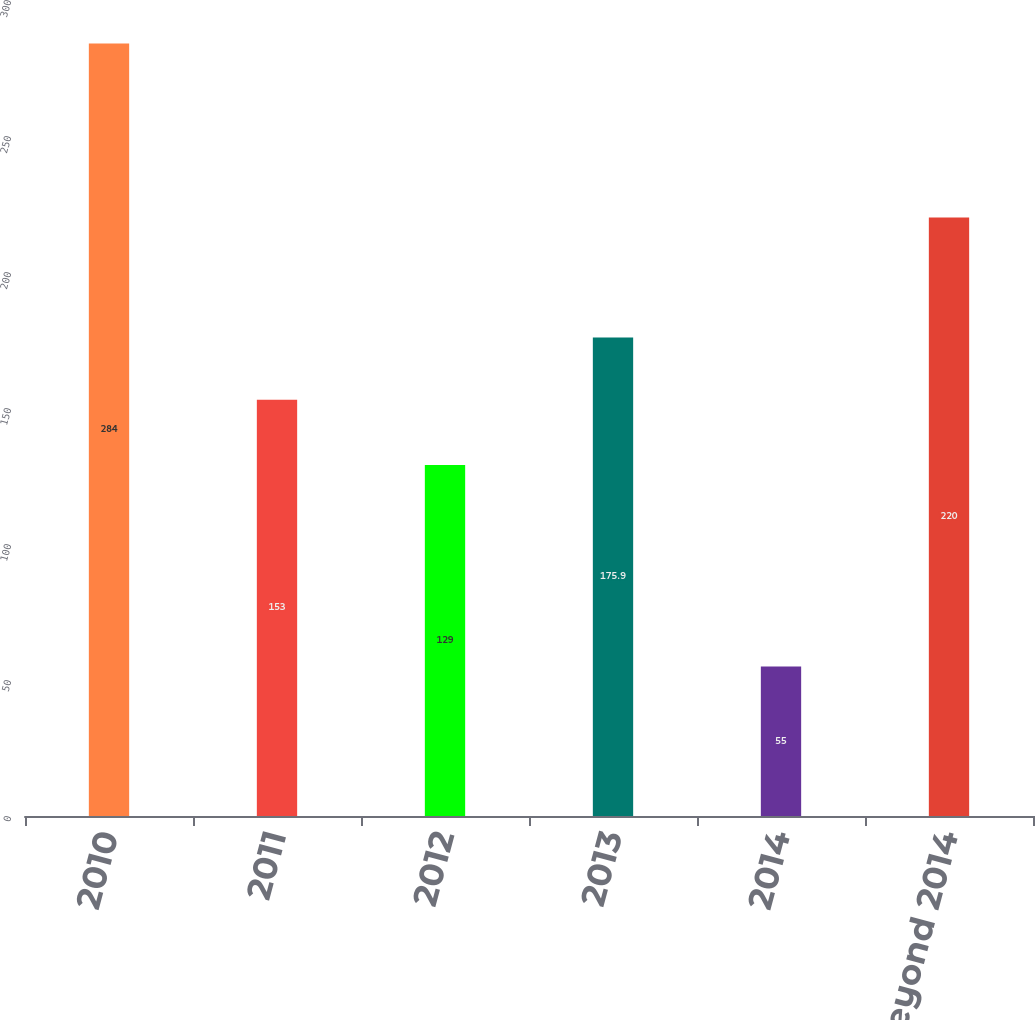Convert chart. <chart><loc_0><loc_0><loc_500><loc_500><bar_chart><fcel>2010<fcel>2011<fcel>2012<fcel>2013<fcel>2014<fcel>Beyond 2014<nl><fcel>284<fcel>153<fcel>129<fcel>175.9<fcel>55<fcel>220<nl></chart> 